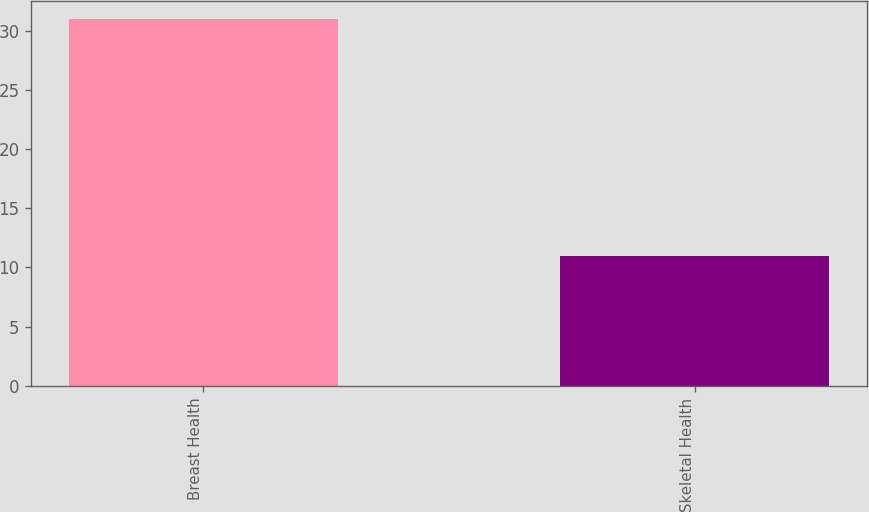Convert chart. <chart><loc_0><loc_0><loc_500><loc_500><bar_chart><fcel>Breast Health<fcel>Skeletal Health<nl><fcel>31<fcel>11<nl></chart> 